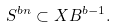Convert formula to latex. <formula><loc_0><loc_0><loc_500><loc_500>S ^ { b n } \subset X B ^ { b - 1 } .</formula> 